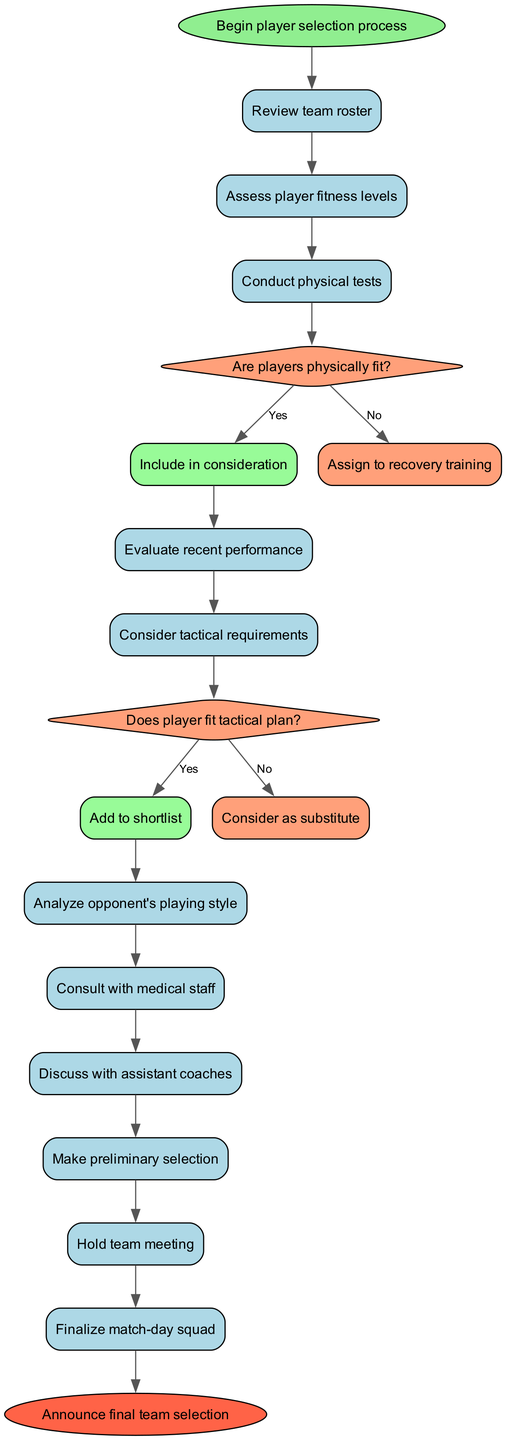What is the starting point of the diagram? The diagram begins with the node labeled "Begin player selection process," which is indicated at the top of the diagram as the start node.
Answer: Begin player selection process How many activities are listed in the diagram? Counting the activities enumerated, there are a total of 10 activities presented in the diagram.
Answer: 10 What occurs after assessing player fitness levels? Following the "Assess player fitness levels" activity, the next activity is "Conduct physical tests," which is directly connected to it in the flow of the diagram.
Answer: Conduct physical tests What happens if a player is not physically fit according to the decision? If a player is determined to be not physically fit, the outcome is "Assign to recovery training," as indicated in the 'no' branch of the first decision node regarding player fitness.
Answer: Assign to recovery training Which activity comes last in the sequence? The final activity in the sequence is "Finalize match-day squad," and it leads directly to the end node of the diagram.
Answer: Finalize match-day squad What must be considered before adding a player to the shortlist? The diagram indicates that a player must fit the tactical plan before they can be added to the shortlist, as outlined in the second decision node.
Answer: Fit tactical plan What is the next action after "Evaluate recent performance"? After "Evaluate recent performance," the diagram indicates that the next action is "Consider tactical requirements," which follows directly in the flow.
Answer: Consider tactical requirements What should be done if a player does not fit the tactical plan? If a player does not fit the tactical plan, they are considered as a substitute, based on the 'no' outcome of the second decision node in the process.
Answer: Consider as substitute Which role is involved in determining the fitness of a player? The decision-making process includes consulting with medical staff, who are responsible for determining the fitness of the players as shown in the list of activities.
Answer: Consult with medical staff 